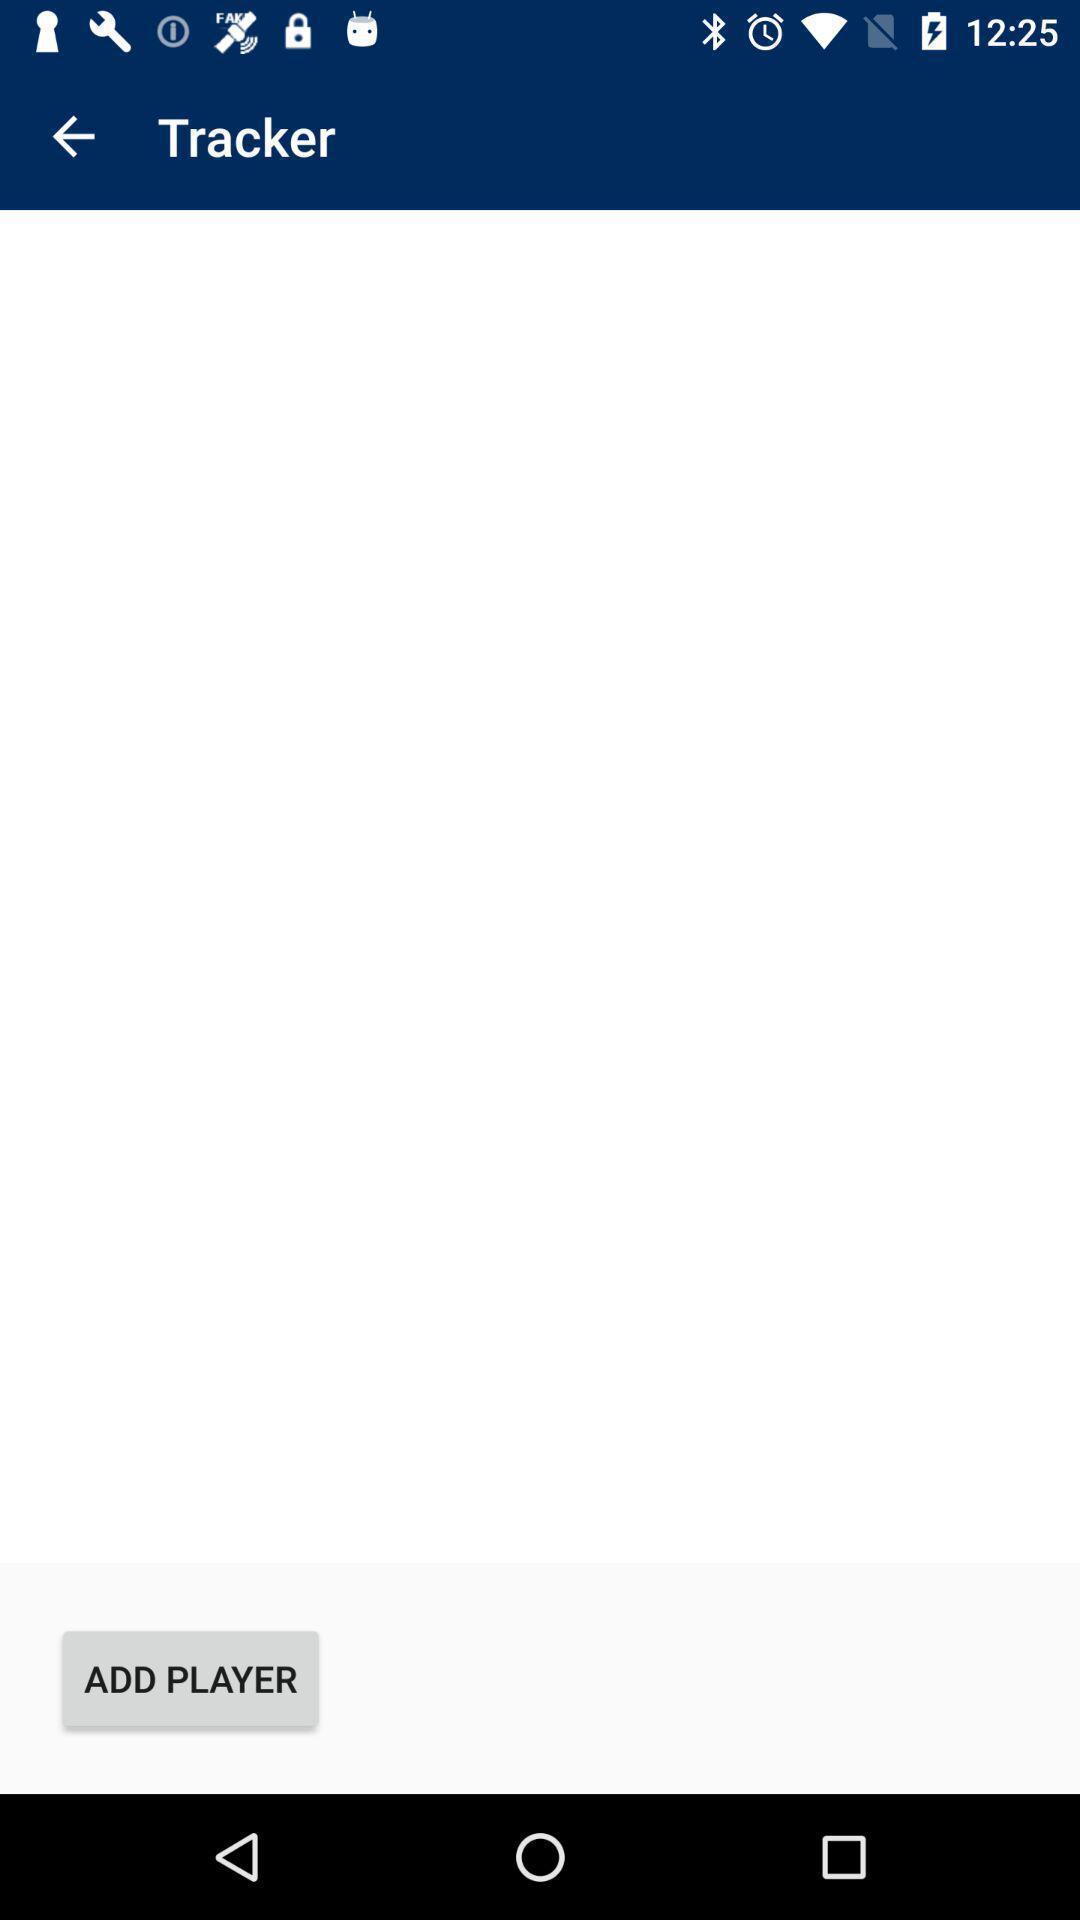Describe the key features of this screenshot. Page showing blank page with option add player. 